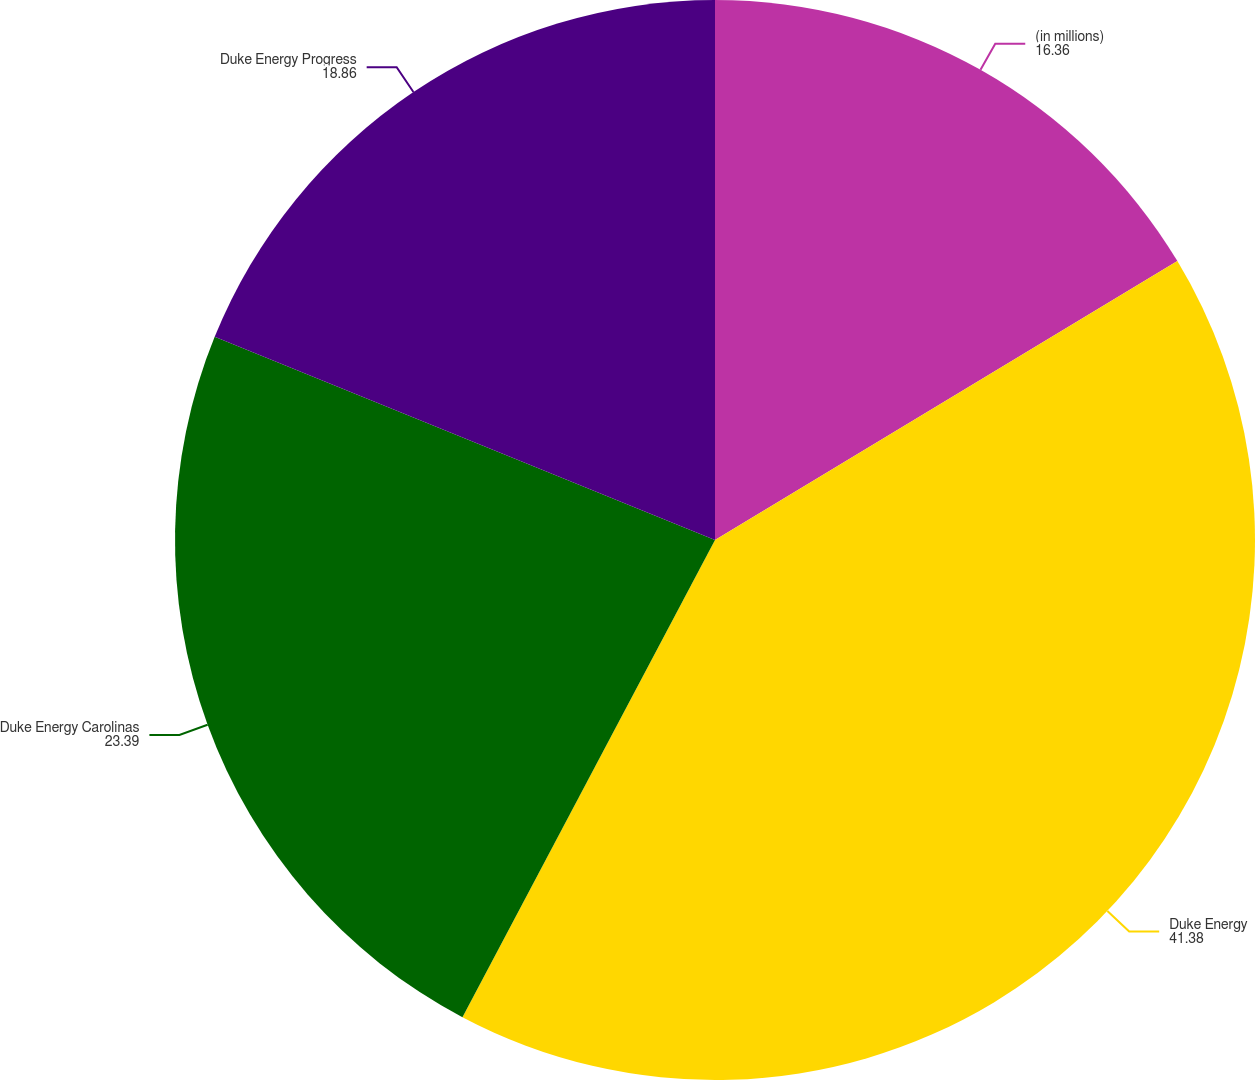Convert chart to OTSL. <chart><loc_0><loc_0><loc_500><loc_500><pie_chart><fcel>(in millions)<fcel>Duke Energy<fcel>Duke Energy Carolinas<fcel>Duke Energy Progress<nl><fcel>16.36%<fcel>41.38%<fcel>23.39%<fcel>18.86%<nl></chart> 